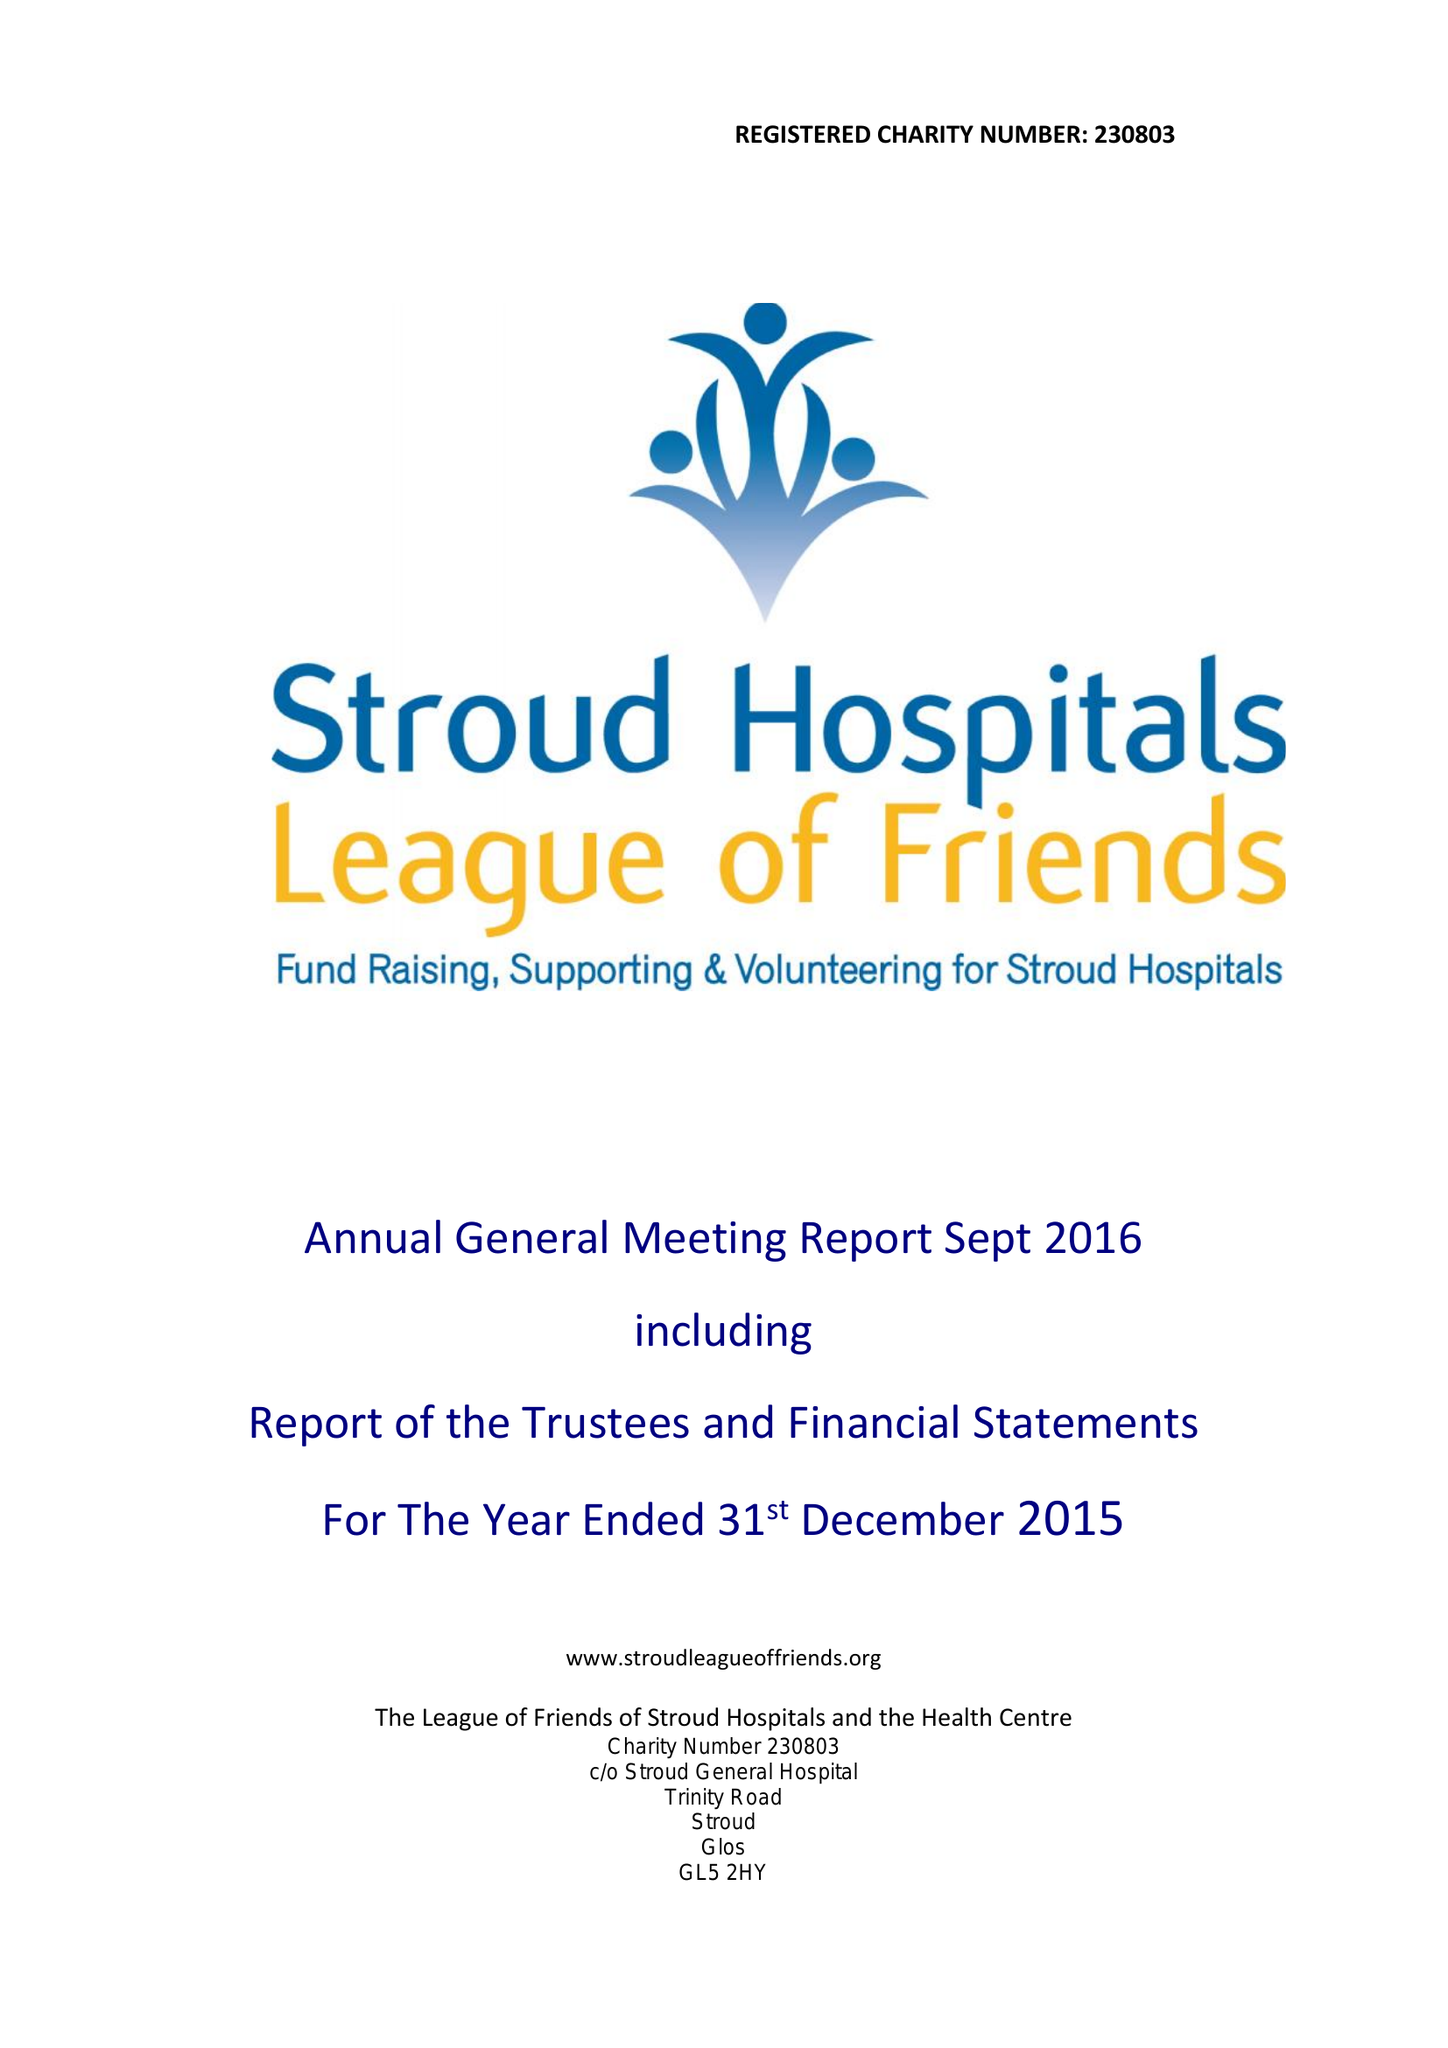What is the value for the charity_number?
Answer the question using a single word or phrase. 230803 